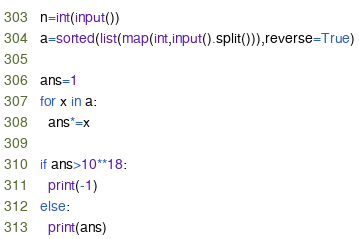Convert code to text. <code><loc_0><loc_0><loc_500><loc_500><_Python_>n=int(input())
a=sorted(list(map(int,input().split())),reverse=True)

ans=1
for x in a:
  ans*=x

if ans>10**18:
  print(-1)
else:
  print(ans)</code> 